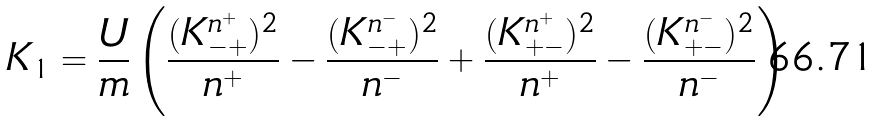Convert formula to latex. <formula><loc_0><loc_0><loc_500><loc_500>K _ { 1 } = \frac { U } { m } \left ( \frac { ( K _ { - + } ^ { n ^ { + } } ) ^ { 2 } } { n ^ { + } } - \frac { ( K _ { - + } ^ { n ^ { - } } ) ^ { 2 } } { n ^ { - } } + \frac { ( K _ { + - } ^ { n ^ { + } } ) ^ { 2 } } { n ^ { + } } - \frac { ( K _ { + - } ^ { n ^ { - } } ) ^ { 2 } } { n ^ { - } } \right )</formula> 